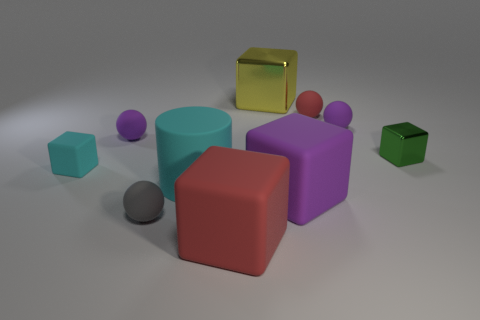Subtract all green cubes. How many cubes are left? 4 Subtract all tiny cyan rubber blocks. How many blocks are left? 4 Subtract all purple blocks. Subtract all red spheres. How many blocks are left? 4 Subtract all cylinders. How many objects are left? 9 Subtract 1 yellow cubes. How many objects are left? 9 Subtract all gray objects. Subtract all large matte blocks. How many objects are left? 7 Add 3 large rubber cylinders. How many large rubber cylinders are left? 4 Add 2 small red objects. How many small red objects exist? 3 